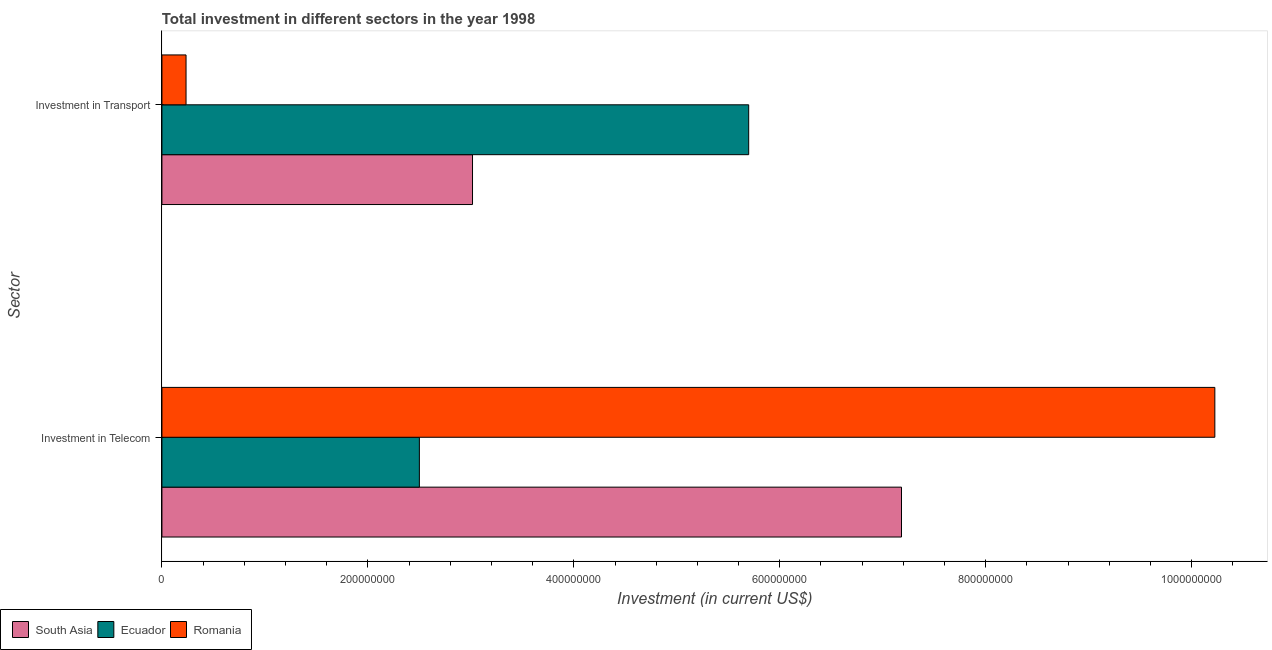How many different coloured bars are there?
Offer a very short reply. 3. How many groups of bars are there?
Make the answer very short. 2. How many bars are there on the 2nd tick from the bottom?
Ensure brevity in your answer.  3. What is the label of the 1st group of bars from the top?
Your answer should be very brief. Investment in Transport. What is the investment in transport in Romania?
Provide a short and direct response. 2.34e+07. Across all countries, what is the maximum investment in transport?
Provide a short and direct response. 5.70e+08. Across all countries, what is the minimum investment in telecom?
Provide a short and direct response. 2.50e+08. In which country was the investment in transport maximum?
Ensure brevity in your answer.  Ecuador. In which country was the investment in transport minimum?
Provide a succinct answer. Romania. What is the total investment in telecom in the graph?
Your answer should be very brief. 1.99e+09. What is the difference between the investment in telecom in South Asia and that in Ecuador?
Ensure brevity in your answer.  4.68e+08. What is the difference between the investment in transport in Ecuador and the investment in telecom in South Asia?
Your response must be concise. -1.48e+08. What is the average investment in telecom per country?
Ensure brevity in your answer.  6.64e+08. What is the difference between the investment in transport and investment in telecom in Ecuador?
Provide a succinct answer. 3.20e+08. What is the ratio of the investment in transport in South Asia to that in Romania?
Offer a very short reply. 12.89. Is the investment in telecom in Romania less than that in Ecuador?
Your answer should be compact. No. What does the 3rd bar from the top in Investment in Telecom represents?
Your answer should be compact. South Asia. What does the 2nd bar from the bottom in Investment in Transport represents?
Make the answer very short. Ecuador. How many countries are there in the graph?
Your answer should be very brief. 3. What is the difference between two consecutive major ticks on the X-axis?
Provide a succinct answer. 2.00e+08. Are the values on the major ticks of X-axis written in scientific E-notation?
Keep it short and to the point. No. Does the graph contain any zero values?
Provide a short and direct response. No. How many legend labels are there?
Make the answer very short. 3. How are the legend labels stacked?
Your response must be concise. Horizontal. What is the title of the graph?
Provide a short and direct response. Total investment in different sectors in the year 1998. What is the label or title of the X-axis?
Provide a succinct answer. Investment (in current US$). What is the label or title of the Y-axis?
Offer a terse response. Sector. What is the Investment (in current US$) of South Asia in Investment in Telecom?
Your answer should be very brief. 7.18e+08. What is the Investment (in current US$) of Ecuador in Investment in Telecom?
Your response must be concise. 2.50e+08. What is the Investment (in current US$) in Romania in Investment in Telecom?
Your response must be concise. 1.02e+09. What is the Investment (in current US$) of South Asia in Investment in Transport?
Your answer should be compact. 3.02e+08. What is the Investment (in current US$) in Ecuador in Investment in Transport?
Keep it short and to the point. 5.70e+08. What is the Investment (in current US$) of Romania in Investment in Transport?
Provide a short and direct response. 2.34e+07. Across all Sector, what is the maximum Investment (in current US$) of South Asia?
Your answer should be compact. 7.18e+08. Across all Sector, what is the maximum Investment (in current US$) of Ecuador?
Provide a succinct answer. 5.70e+08. Across all Sector, what is the maximum Investment (in current US$) of Romania?
Your response must be concise. 1.02e+09. Across all Sector, what is the minimum Investment (in current US$) in South Asia?
Provide a succinct answer. 3.02e+08. Across all Sector, what is the minimum Investment (in current US$) of Ecuador?
Give a very brief answer. 2.50e+08. Across all Sector, what is the minimum Investment (in current US$) of Romania?
Offer a very short reply. 2.34e+07. What is the total Investment (in current US$) of South Asia in the graph?
Make the answer very short. 1.02e+09. What is the total Investment (in current US$) of Ecuador in the graph?
Your response must be concise. 8.20e+08. What is the total Investment (in current US$) of Romania in the graph?
Your answer should be very brief. 1.05e+09. What is the difference between the Investment (in current US$) in South Asia in Investment in Telecom and that in Investment in Transport?
Provide a succinct answer. 4.17e+08. What is the difference between the Investment (in current US$) in Ecuador in Investment in Telecom and that in Investment in Transport?
Provide a short and direct response. -3.20e+08. What is the difference between the Investment (in current US$) in Romania in Investment in Telecom and that in Investment in Transport?
Provide a short and direct response. 9.99e+08. What is the difference between the Investment (in current US$) in South Asia in Investment in Telecom and the Investment (in current US$) in Ecuador in Investment in Transport?
Keep it short and to the point. 1.48e+08. What is the difference between the Investment (in current US$) of South Asia in Investment in Telecom and the Investment (in current US$) of Romania in Investment in Transport?
Offer a very short reply. 6.95e+08. What is the difference between the Investment (in current US$) in Ecuador in Investment in Telecom and the Investment (in current US$) in Romania in Investment in Transport?
Offer a very short reply. 2.27e+08. What is the average Investment (in current US$) of South Asia per Sector?
Offer a very short reply. 5.10e+08. What is the average Investment (in current US$) in Ecuador per Sector?
Make the answer very short. 4.10e+08. What is the average Investment (in current US$) of Romania per Sector?
Your answer should be compact. 5.23e+08. What is the difference between the Investment (in current US$) of South Asia and Investment (in current US$) of Ecuador in Investment in Telecom?
Provide a short and direct response. 4.68e+08. What is the difference between the Investment (in current US$) of South Asia and Investment (in current US$) of Romania in Investment in Telecom?
Your answer should be very brief. -3.04e+08. What is the difference between the Investment (in current US$) in Ecuador and Investment (in current US$) in Romania in Investment in Telecom?
Ensure brevity in your answer.  -7.72e+08. What is the difference between the Investment (in current US$) of South Asia and Investment (in current US$) of Ecuador in Investment in Transport?
Give a very brief answer. -2.68e+08. What is the difference between the Investment (in current US$) in South Asia and Investment (in current US$) in Romania in Investment in Transport?
Provide a succinct answer. 2.78e+08. What is the difference between the Investment (in current US$) in Ecuador and Investment (in current US$) in Romania in Investment in Transport?
Provide a short and direct response. 5.46e+08. What is the ratio of the Investment (in current US$) in South Asia in Investment in Telecom to that in Investment in Transport?
Your answer should be very brief. 2.38. What is the ratio of the Investment (in current US$) in Ecuador in Investment in Telecom to that in Investment in Transport?
Your response must be concise. 0.44. What is the ratio of the Investment (in current US$) in Romania in Investment in Telecom to that in Investment in Transport?
Your answer should be very brief. 43.7. What is the difference between the highest and the second highest Investment (in current US$) of South Asia?
Make the answer very short. 4.17e+08. What is the difference between the highest and the second highest Investment (in current US$) in Ecuador?
Keep it short and to the point. 3.20e+08. What is the difference between the highest and the second highest Investment (in current US$) in Romania?
Your answer should be very brief. 9.99e+08. What is the difference between the highest and the lowest Investment (in current US$) in South Asia?
Your response must be concise. 4.17e+08. What is the difference between the highest and the lowest Investment (in current US$) in Ecuador?
Your response must be concise. 3.20e+08. What is the difference between the highest and the lowest Investment (in current US$) in Romania?
Keep it short and to the point. 9.99e+08. 